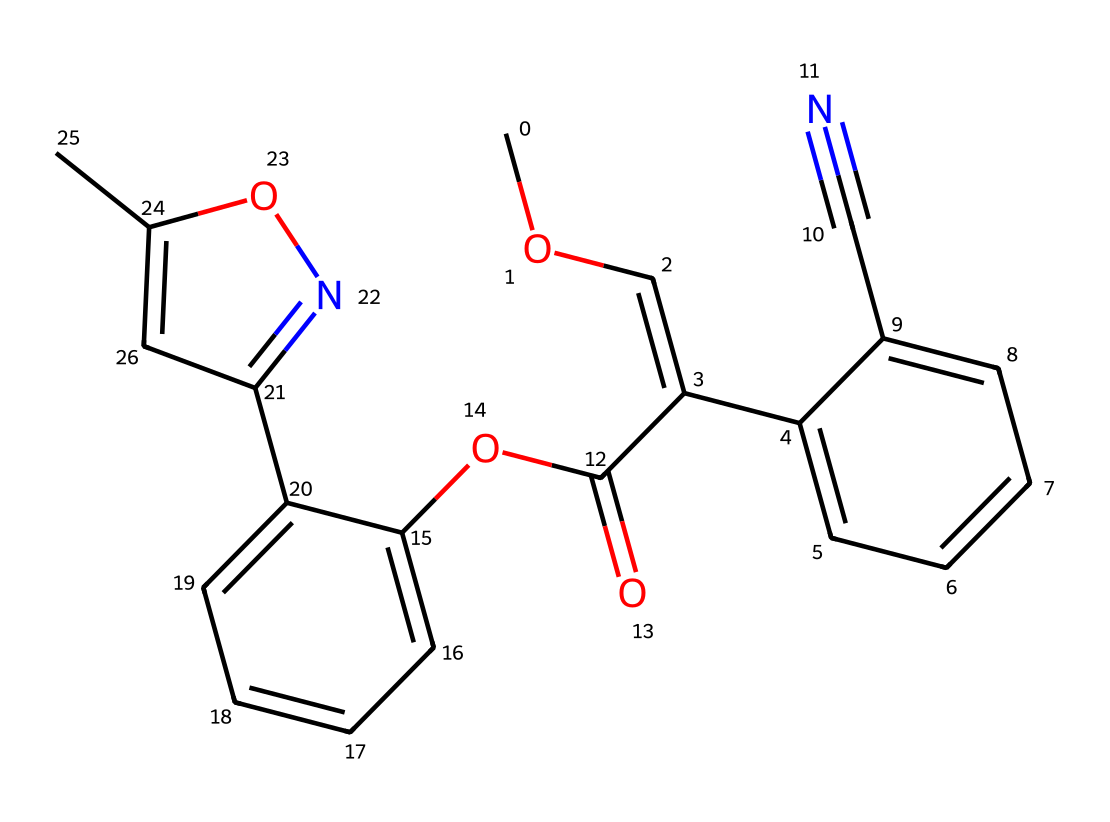What is the molecular formula of azoxystrobin? By analyzing the SMILES representation, we can determine the molecular formula by counting the types of atoms present. The counted atoms provide the formula: C15H14N4O4.
Answer: C15H14N4O4 How many rings are present in the azoxystrobin structure? In the SMILES, we identify the "C" characters followed by numbers, which indicate the formation of rings. There are two sets of numbers showing that there are two distinct cycles in the structure.
Answer: 2 What functional groups are present in azoxystrobin? By examining the chemical structure derived from the SMILES, we note the presence of ester (OC(=O)O) and nitrogen functionalities, indicating that the compound is a carboxylic ester and has a nitrogen-containing component.
Answer: ester and nitrogen What is the primary use of azoxystrobin? As a broad-spectrum fungicide, azoxystrobin is primarily used in agriculture to control various fungal pathogens in crops. The role of this compound as a fungicide is a key property of its design.
Answer: fungicide Which atom in azoxystrobin contributes to its antifungal properties? The nitrogen atoms (N) within the structure are often key contributors to the bioactivity of fungicides. In azoxystrobin, the nitrogen in the pyridine-like structure plays a critical role in its fungicidal action.
Answer: nitrogen What type of chemical is azoxystrobin classified as? Azoxystrobin is classified specifically as a strobilurin fungicide, which is noted in its structure through the aromatic systems and nitrogen functionalities connected to a butenyl and carboxylic structure.
Answer: strobilurin 